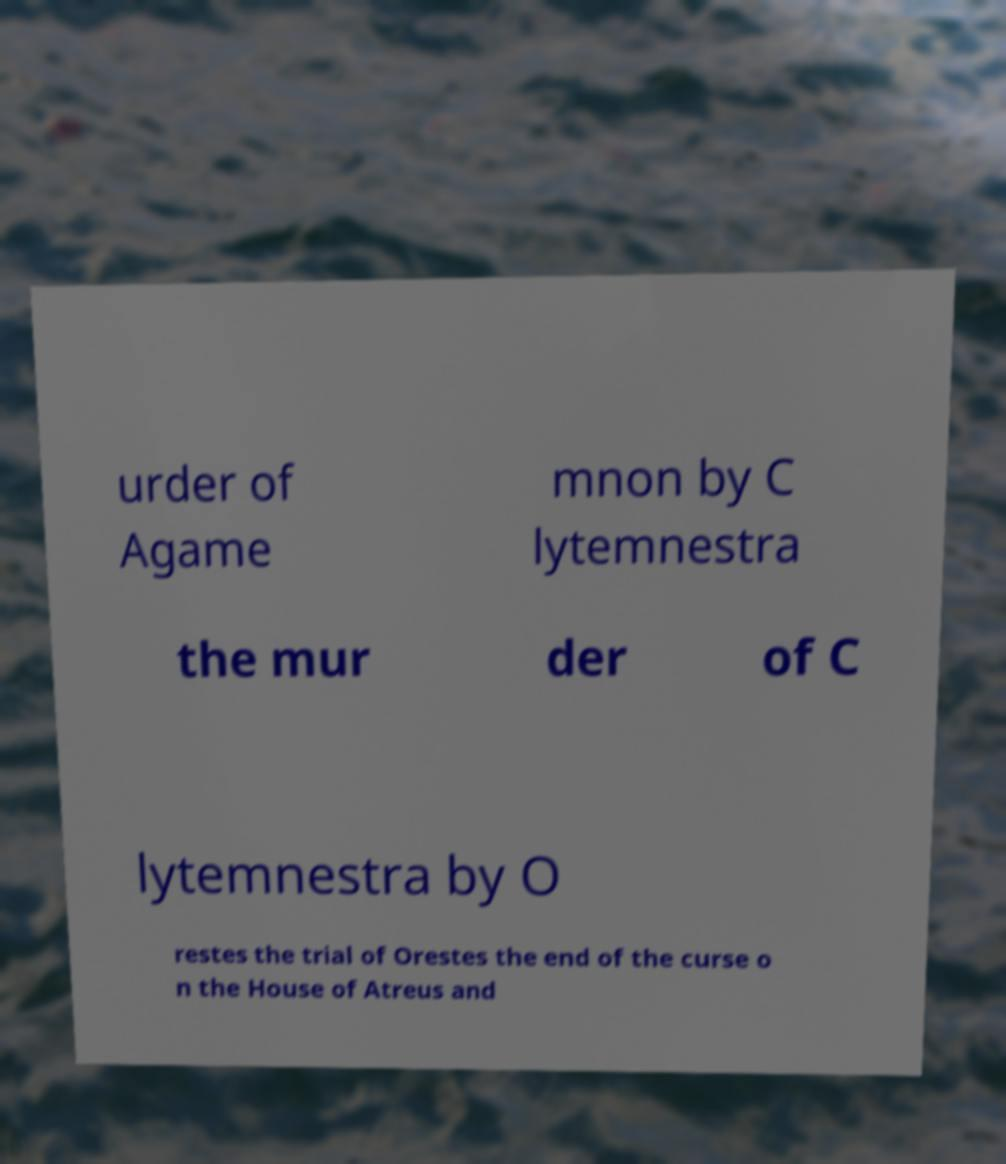Could you assist in decoding the text presented in this image and type it out clearly? urder of Agame mnon by C lytemnestra the mur der of C lytemnestra by O restes the trial of Orestes the end of the curse o n the House of Atreus and 